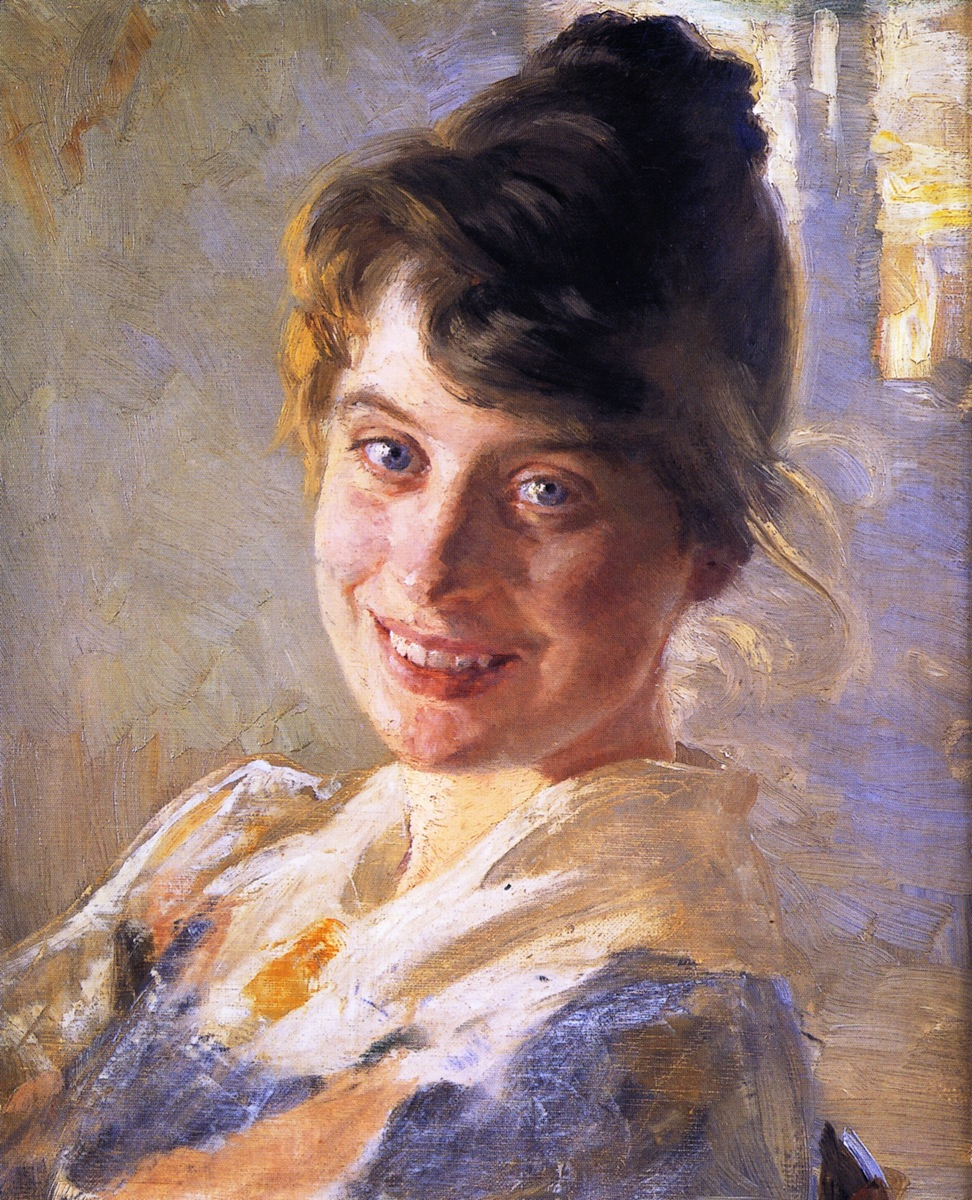Write a detailed description of the given image. The image is a portrait of a young woman painted in an impressionist style. She has a warm and inviting smile that imparts a cheerful and light-hearted mood to the piece. She wears a white blouse with blue stripes, and her hair is fashionably arranged in a bun, with a few strands playfully escaping. The background is an amalgamation of soft light blues and yellows, contributing to the painting’s airy and serene atmosphere. The artist employs loose brushstrokes and a vibrant color palette typical of the impressionist genre. Overall, the composition and delicate use of light and color come together to evoke a sense of warmth and joy. 